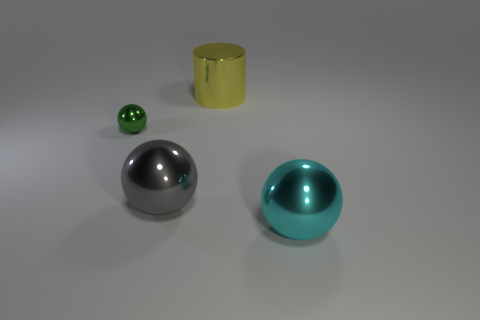Subtract all small green balls. How many balls are left? 2 Subtract 1 balls. How many balls are left? 2 Add 2 green metallic things. How many objects exist? 6 Subtract all cylinders. How many objects are left? 3 Add 1 large cylinders. How many large cylinders are left? 2 Add 4 green matte balls. How many green matte balls exist? 4 Subtract 0 blue cylinders. How many objects are left? 4 Subtract all rubber objects. Subtract all tiny shiny objects. How many objects are left? 3 